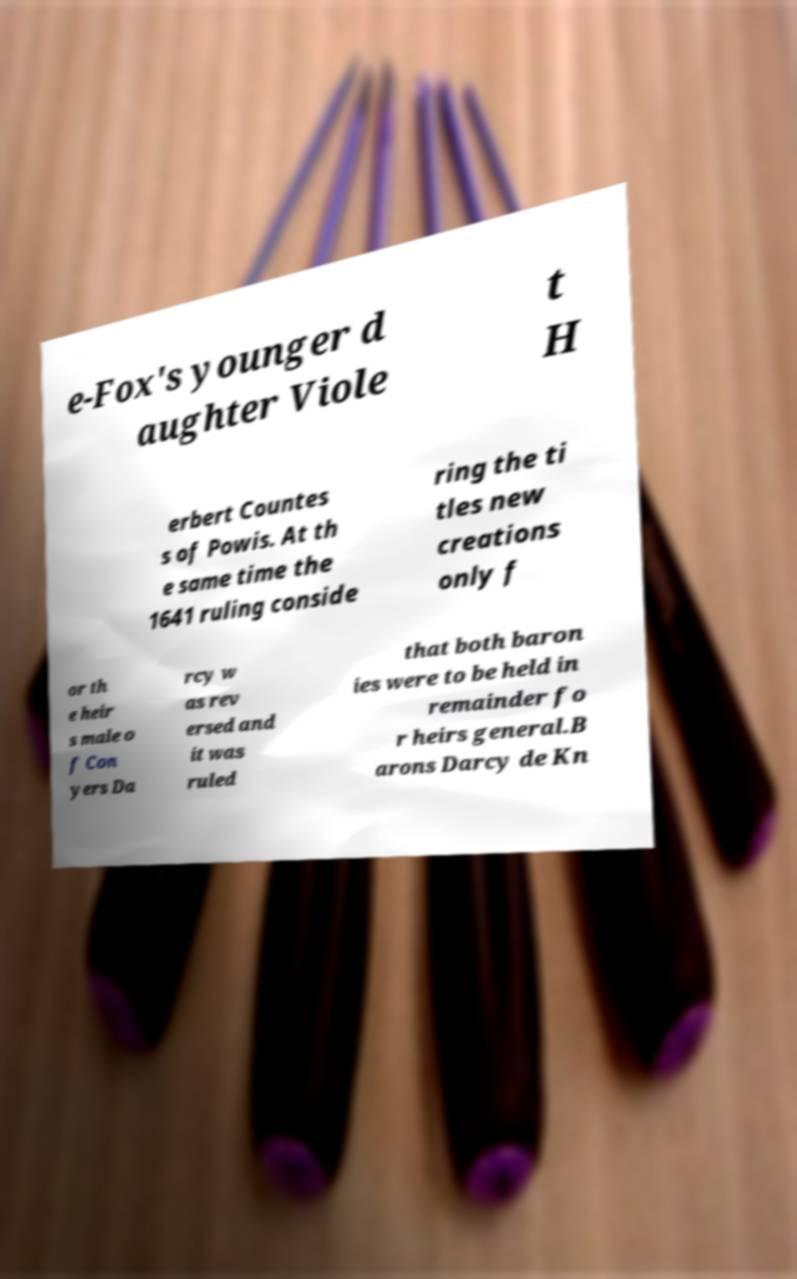Can you accurately transcribe the text from the provided image for me? e-Fox's younger d aughter Viole t H erbert Countes s of Powis. At th e same time the 1641 ruling conside ring the ti tles new creations only f or th e heir s male o f Con yers Da rcy w as rev ersed and it was ruled that both baron ies were to be held in remainder fo r heirs general.B arons Darcy de Kn 